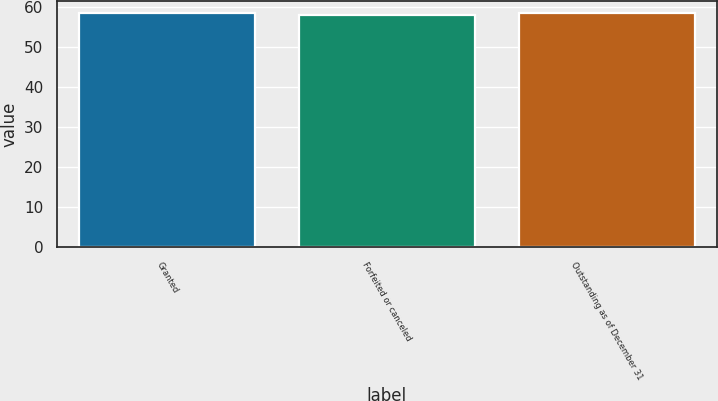Convert chart. <chart><loc_0><loc_0><loc_500><loc_500><bar_chart><fcel>Granted<fcel>Forfeited or canceled<fcel>Outstanding as of December 31<nl><fcel>58.4<fcel>58.02<fcel>58.44<nl></chart> 